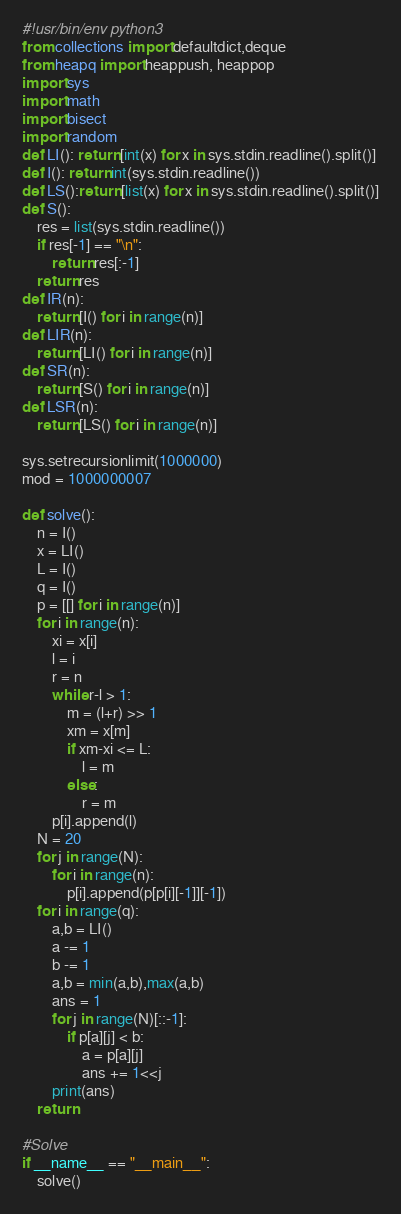Convert code to text. <code><loc_0><loc_0><loc_500><loc_500><_Python_>#!usr/bin/env python3
from collections import defaultdict,deque
from heapq import heappush, heappop
import sys
import math
import bisect
import random
def LI(): return [int(x) for x in sys.stdin.readline().split()]
def I(): return int(sys.stdin.readline())
def LS():return [list(x) for x in sys.stdin.readline().split()]
def S():
    res = list(sys.stdin.readline())
    if res[-1] == "\n":
        return res[:-1]
    return res
def IR(n):
    return [I() for i in range(n)]
def LIR(n):
    return [LI() for i in range(n)]
def SR(n):
    return [S() for i in range(n)]
def LSR(n):
    return [LS() for i in range(n)]

sys.setrecursionlimit(1000000)
mod = 1000000007

def solve():
    n = I()
    x = LI()
    L = I()
    q = I()
    p = [[] for i in range(n)]
    for i in range(n):
        xi = x[i]
        l = i
        r = n
        while r-l > 1:
            m = (l+r) >> 1
            xm = x[m]
            if xm-xi <= L:
                l = m
            else:
                r = m
        p[i].append(l)
    N = 20
    for j in range(N):
        for i in range(n):
            p[i].append(p[p[i][-1]][-1])
    for i in range(q):
        a,b = LI()
        a -= 1
        b -= 1
        a,b = min(a,b),max(a,b)
        ans = 1
        for j in range(N)[::-1]:
            if p[a][j] < b:
                a = p[a][j]
                ans += 1<<j
        print(ans)
    return

#Solve
if __name__ == "__main__":
    solve()
</code> 